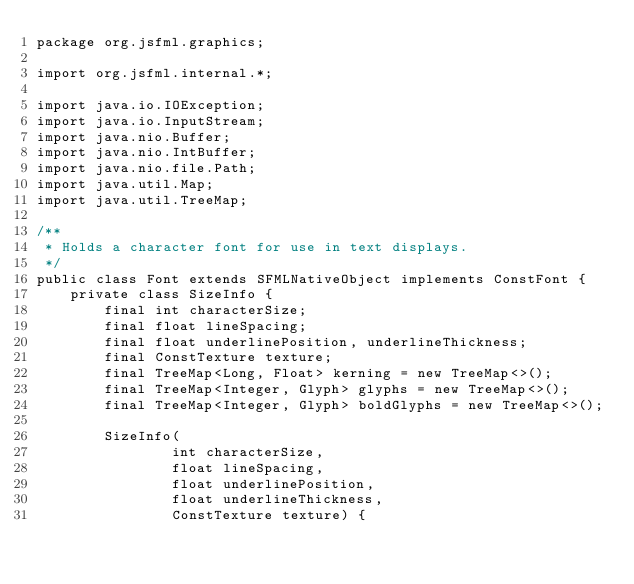Convert code to text. <code><loc_0><loc_0><loc_500><loc_500><_Java_>package org.jsfml.graphics;

import org.jsfml.internal.*;

import java.io.IOException;
import java.io.InputStream;
import java.nio.Buffer;
import java.nio.IntBuffer;
import java.nio.file.Path;
import java.util.Map;
import java.util.TreeMap;

/**
 * Holds a character font for use in text displays.
 */
public class Font extends SFMLNativeObject implements ConstFont {
    private class SizeInfo {
        final int characterSize;
        final float lineSpacing;
        final float underlinePosition, underlineThickness;
        final ConstTexture texture;
        final TreeMap<Long, Float> kerning = new TreeMap<>();
        final TreeMap<Integer, Glyph> glyphs = new TreeMap<>();
        final TreeMap<Integer, Glyph> boldGlyphs = new TreeMap<>();

        SizeInfo(
                int characterSize,
                float lineSpacing,
                float underlinePosition,
                float underlineThickness,
                ConstTexture texture) {
</code> 